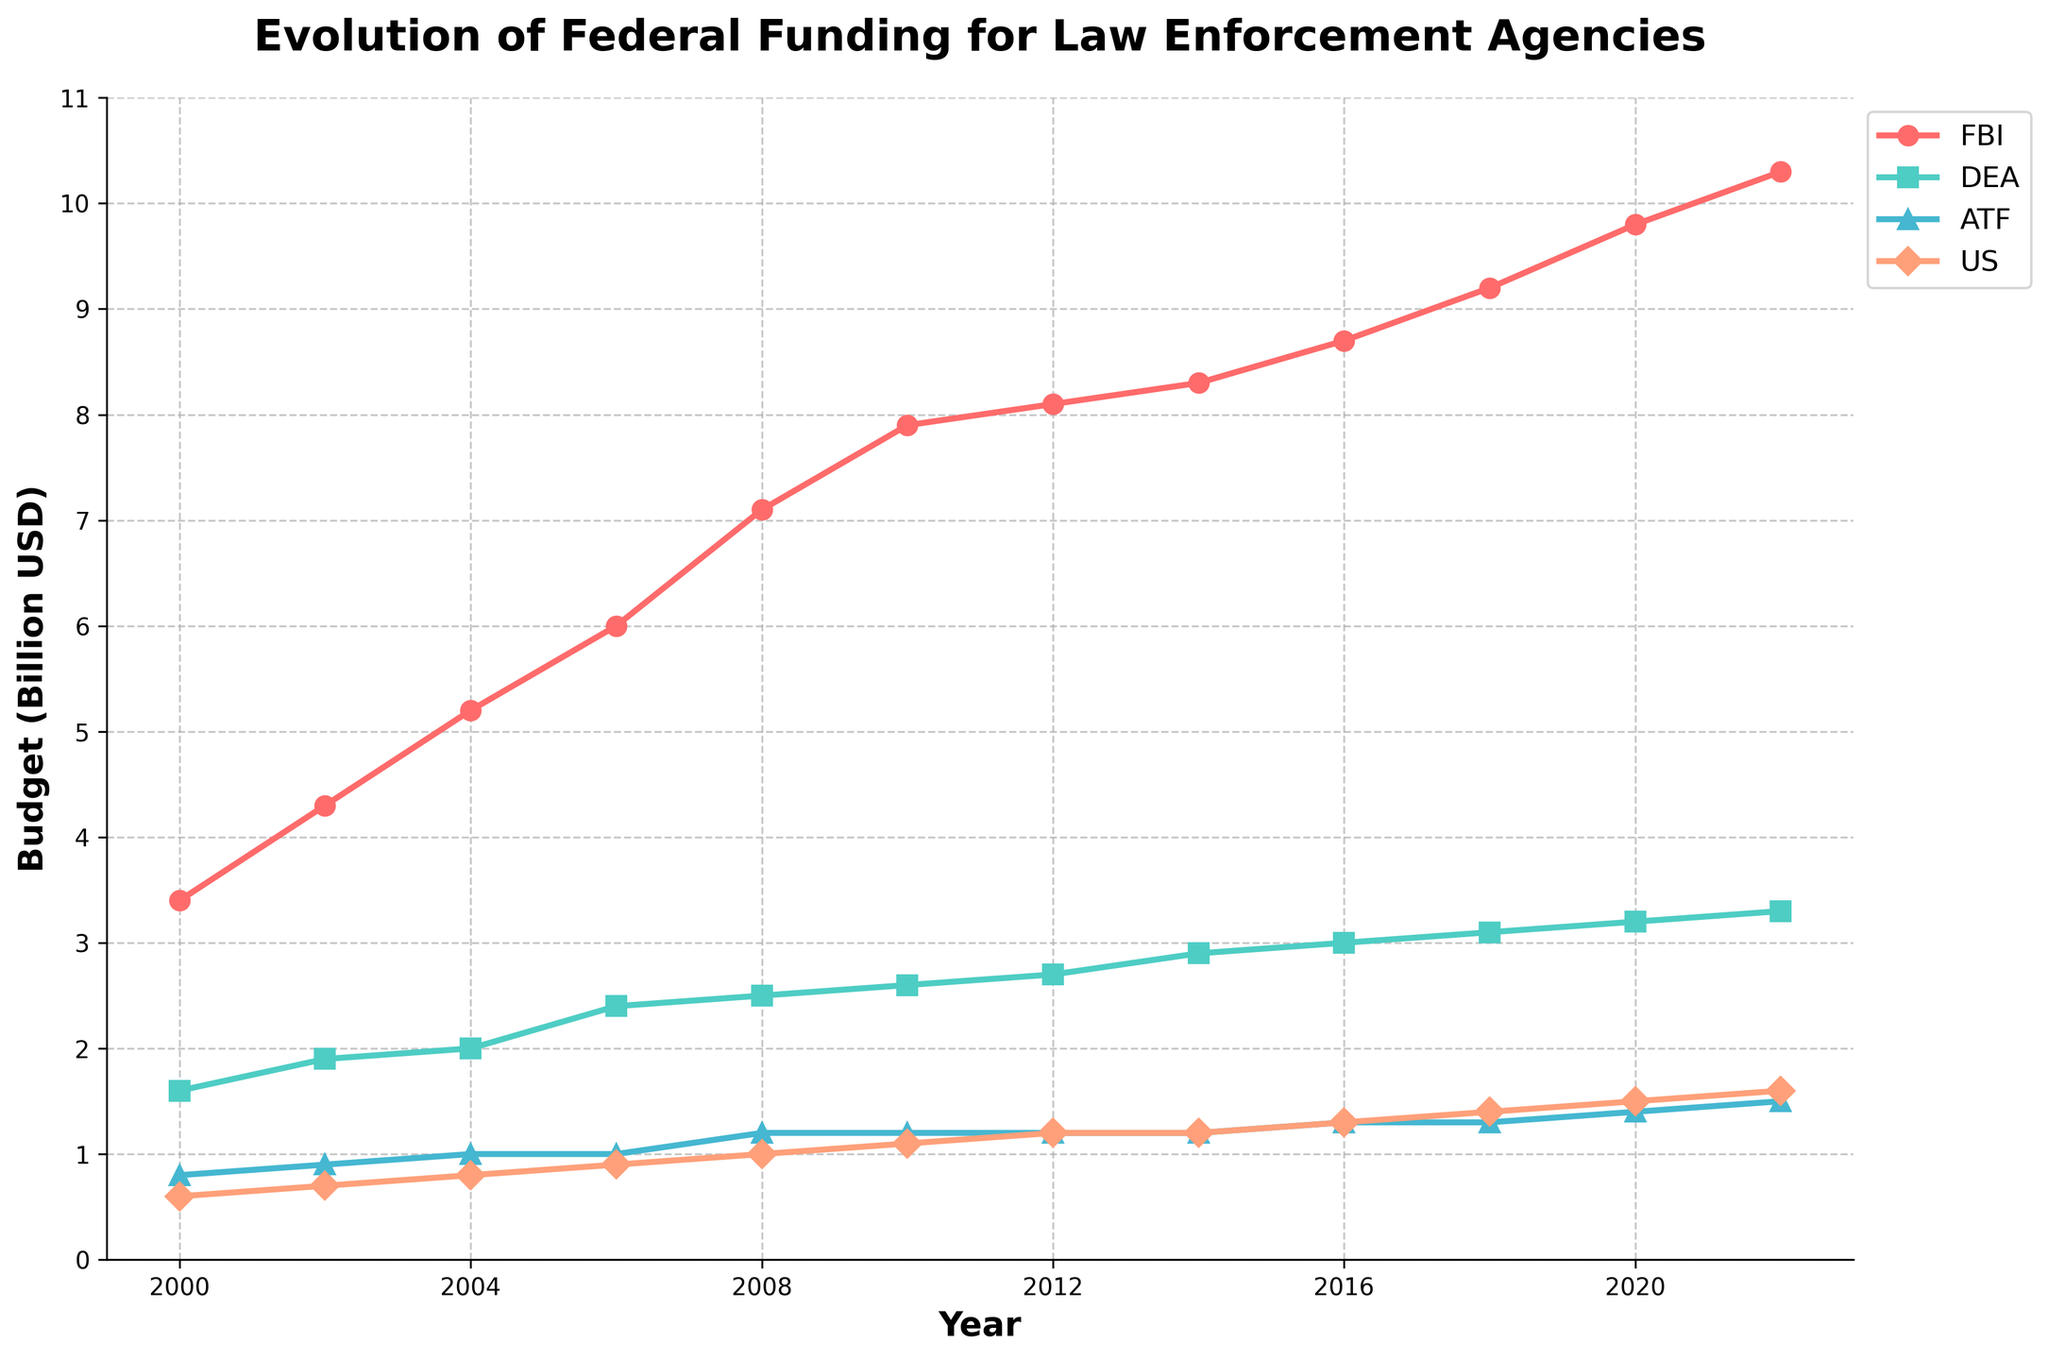What's the combined budget for all agencies in 2022? To find the combined budget, sum the budgets of all four agencies for the year 2022: FBI (10.3), DEA (3.3), ATF (1.5), and US Marshals Service (1.6). The total is 10.3 + 3.3 + 1.5 + 1.6 = 16.7 billion USD
Answer: 16.7 billion USD Which agency received the highest federal funding throughout the years? By examining the plotted lines, we can observe that the FBI budget is consistently the highest among all agencies for each year.
Answer: FBI What is the budget increase for the DEA from 2000 to 2022? The DEA budget in 2000 was 1.6 billion USD, and in 2022 it was 3.3 billion USD. The increase is 3.3 - 1.6 = 1.7 billion USD.
Answer: 1.7 billion USD How much more funding did the FBI receive compared to the US Marshals Service in 2022? In 2022, the FBI received 10.3 billion USD, while the US Marshals Service received 1.6 billion USD. The difference is 10.3 - 1.6 = 8.7 billion USD.
Answer: 8.7 billion USD Which agency had the least budget increase from 2000 to 2022? The budgets in 2000 and 2022 were as follows: FBI (3.4 to 10.3), DEA (1.6 to 3.3), ATF (0.8 to 1.5), and US Marshals Service (0.6 to 1.6). The increases are: FBI (6.9), DEA (1.7), ATF (0.7), and US Marshals Service (1.0). The ATF had the smallest increase of 0.7 billion USD.
Answer: ATF Which year did the DEA’s budget reach 2.5 billion USD? By analyzing the plot, we see that the DEA’s budget reached 2.5 billion USD in the year 2008.
Answer: 2008 What’s the average budget of the FBI over the entire period from 2000 to 2022? First, sum all the yearly budgets of the FBI from 2000 to 2022: 3.4 + 4.3 + 5.2 + 6.0 + 7.1 + 7.9 + 8.1 + 8.3 + 8.7 + 9.2 + 9.8 + 10.3. This equals 88.3 billion USD. Divide by the number of years (12), getting 88.3 / 12 = 7.36 billion USD.
Answer: 7.36 billion USD Between which two consecutive years did the FBI’s budget increase the most? To find the largest increase, compute the budget changes between each pair of consecutive years and compare: 
2000-2002: 0.9, 
2002-2004: 0.9, 
2004-2006: 0.8, 
2006-2008: 1.1, 
2008-2010: 0.8, 
2010-2012: 0.2, 
2012-2014: 0.2, 
2014-2016: 0.4, 
2016-2018: 0.5, 
2018-2020: 0.6, 
2020-2022: 0.5. 
The largest increase was between 2006 and 2008, which is 1.1 billion USD.
Answer: 2006-2008 